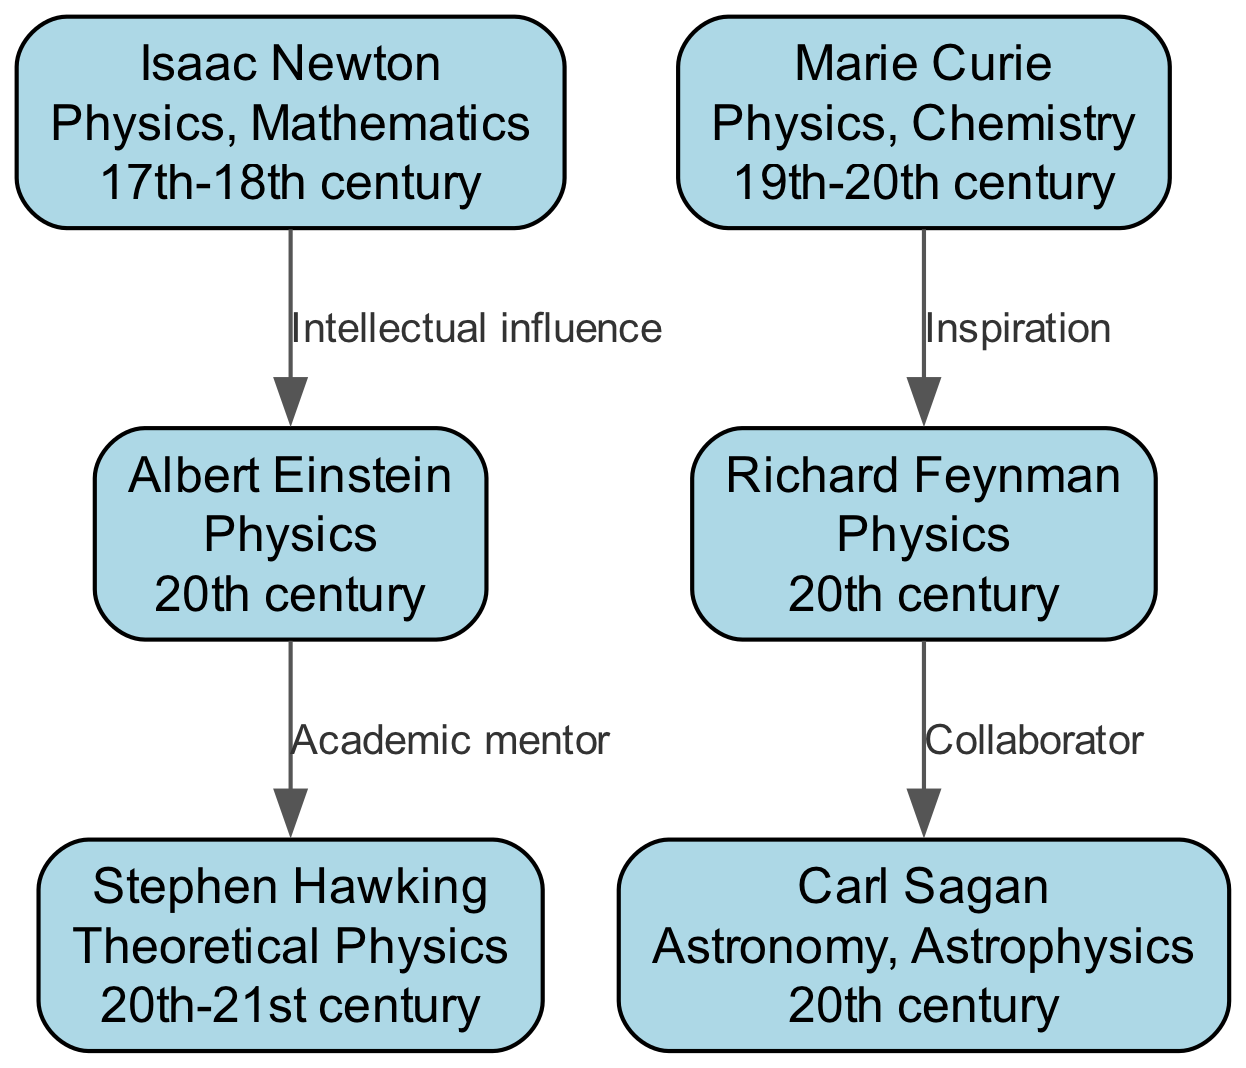What is the era of Isaac Newton? The diagram indicates that Isaac Newton's era is specified as the "17th-18th century." This information is retrieved directly from the node representing Isaac Newton in the diagram.
Answer: 17th-18th century Who inspired Richard Feynman? According to the diagram, the relationship noted is "Inspiration," which signifies that Marie Curie inspired Richard Feynman. This relationship is indicated by the edge connecting Curie and Feynman.
Answer: Marie Curie How many total scientists are included in the family tree? The diagram displays a total of 6 unique nodes representing scientists. This count can be obtained by simply counting each node listed in the diagram.
Answer: 6 Who did Albert Einstein mentor academically? The relationship highlighted in the diagram shows that Albert Einstein served as the "Academic mentor" to Stephen Hawking. This is directly indicated by the edge connecting Einstein to Hawking.
Answer: Stephen Hawking Which scientist was inspired by Marie Curie? The diagram explicitly details that Richard Feynman was inspired by Marie Curie, as shown by the "Inspiration" relationship that links the two scientists.
Answer: Richard Feynman What type of relationship exists between Richard Feynman and Carl Sagan? The diagram illustrates that the relationship between Richard Feynman and Carl Sagan is one of "Collaborator." This can be verified by looking at the edge that connects the two nodes.
Answer: Collaborator How many edges are connecting the scientists in the diagram? The diagram contains 4 edges that illustrate the various relationships between the scientists. This number can be counted by examining the connections made between the nodes.
Answer: 4 What field does Stephen Hawking specialize in? From the information on the diagram, it is indicated that Stephen Hawking specializes in "Theoretical Physics." This is presented in the description within his corresponding node.
Answer: Theoretical Physics 